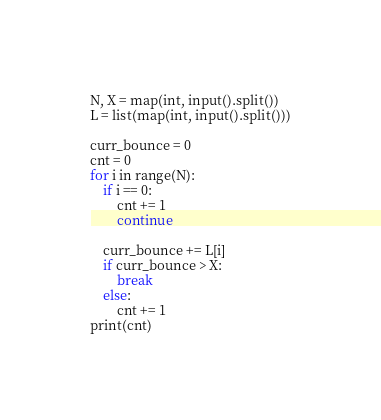<code> <loc_0><loc_0><loc_500><loc_500><_Python_>N, X = map(int, input().split())
L = list(map(int, input().split()))

curr_bounce = 0
cnt = 0
for i in range(N):
    if i == 0:
        cnt += 1
        continue

    curr_bounce += L[i]
    if curr_bounce > X:
        break
    else:
        cnt += 1
print(cnt)</code> 